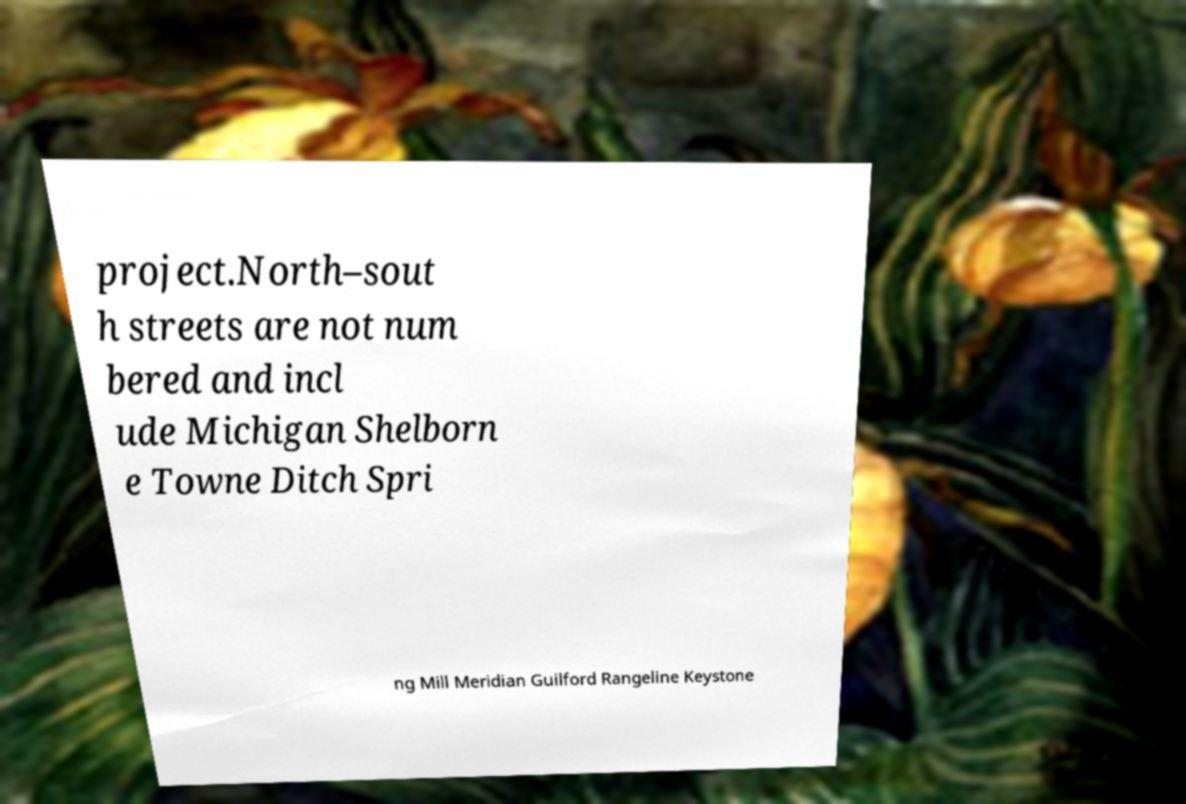I need the written content from this picture converted into text. Can you do that? project.North–sout h streets are not num bered and incl ude Michigan Shelborn e Towne Ditch Spri ng Mill Meridian Guilford Rangeline Keystone 